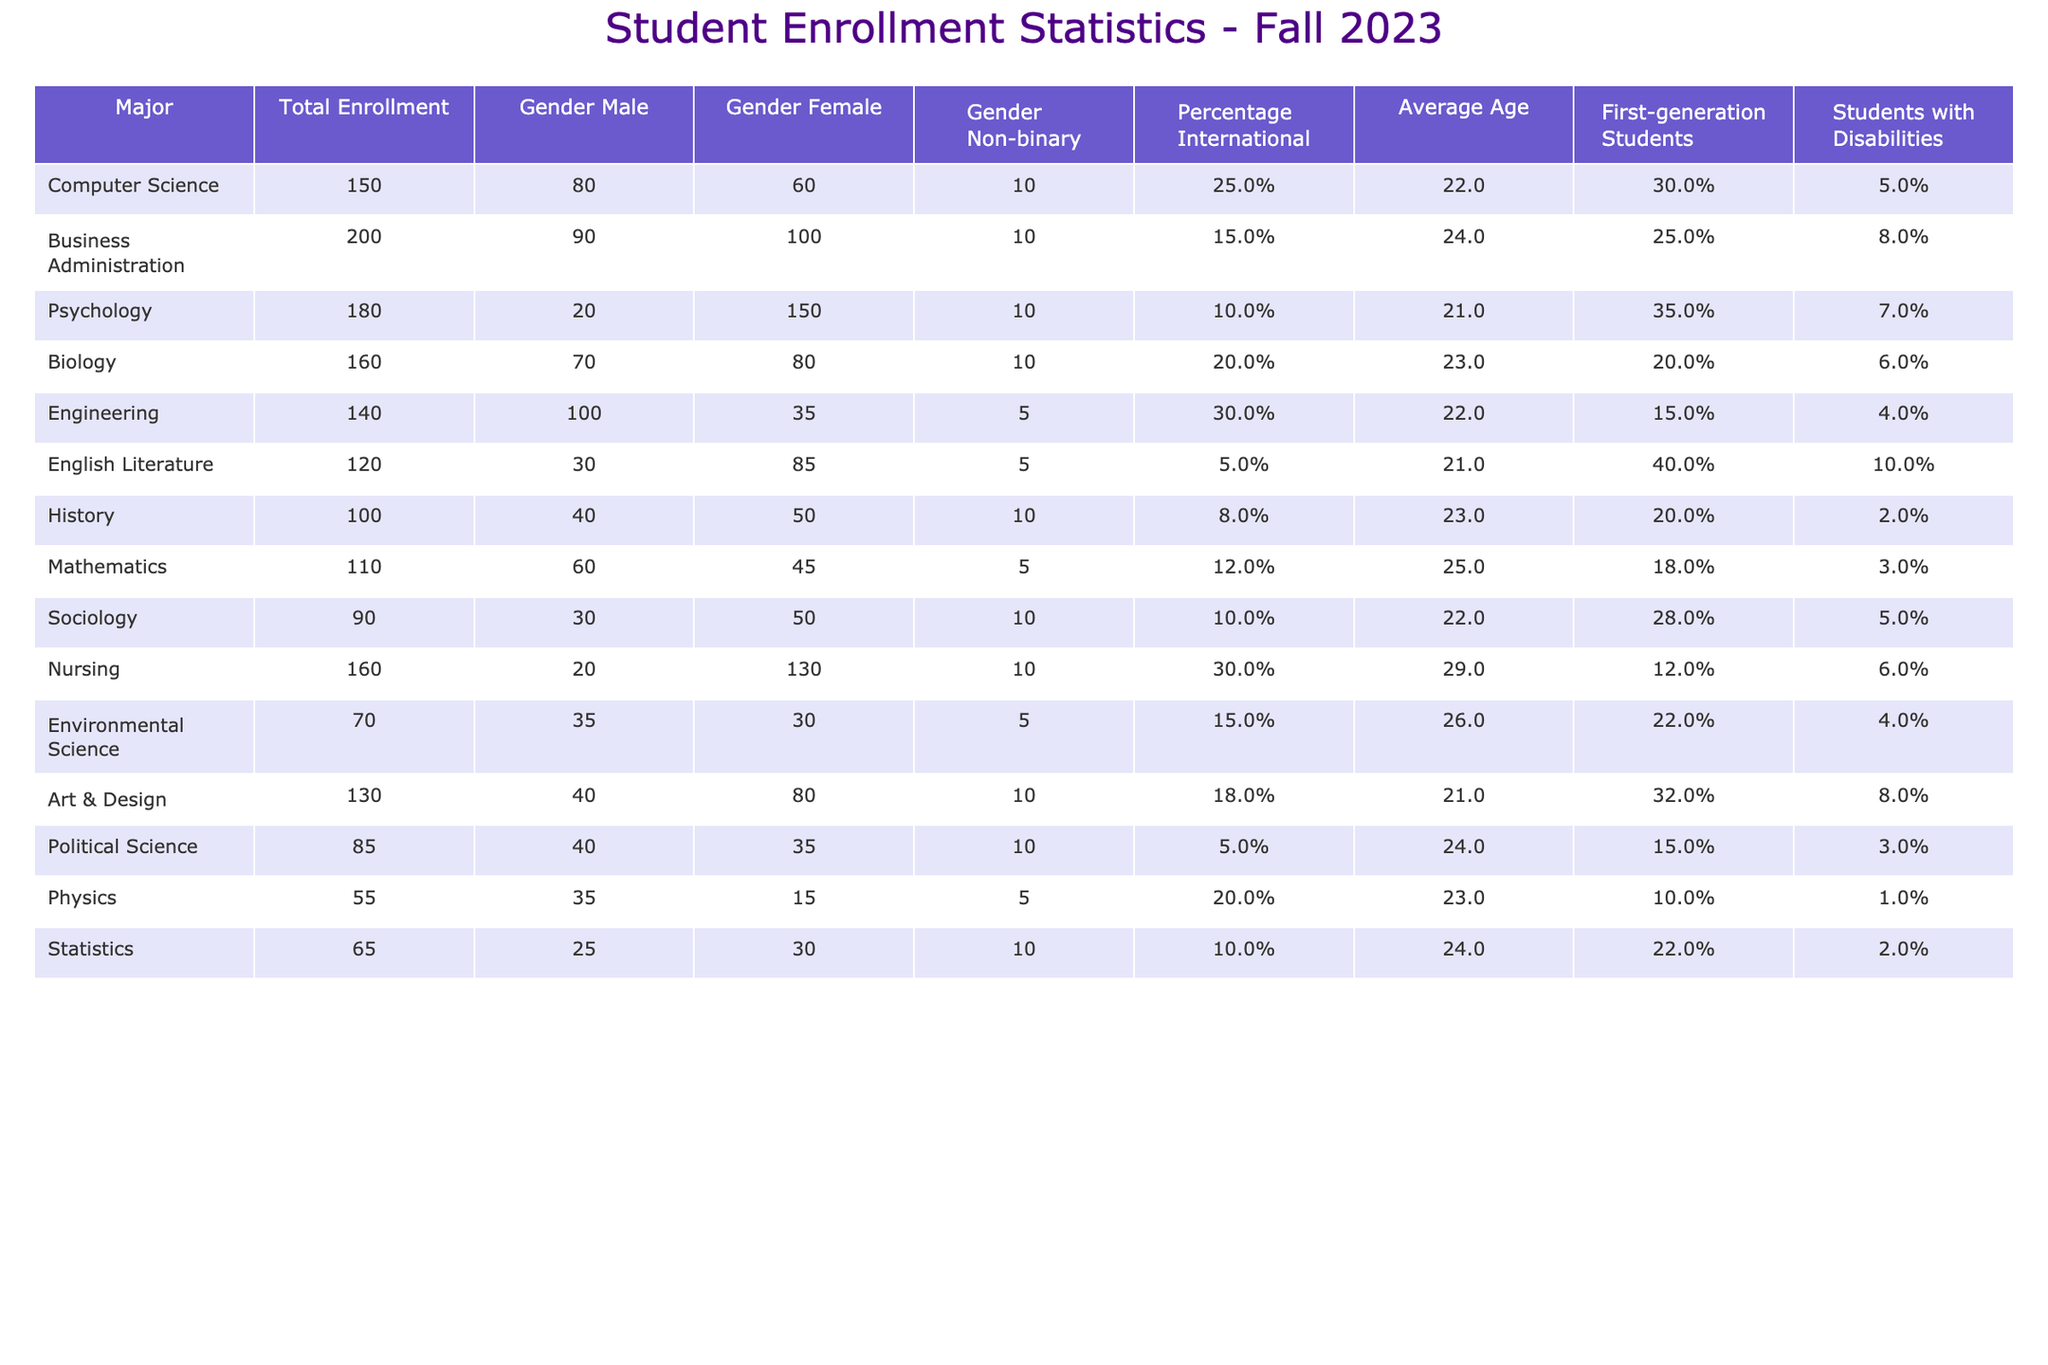What is the total enrollment for Computer Science? The table shows the "Total Enrollment" column for each major, where Computer Science has a recorded value of 150.
Answer: 150 How many female students are enrolled in Nursing? In the Nursing row under "Gender Female", the number of female students is 130.
Answer: 130 What is the average age of students in the Psychology major? The table lists the "Average Age" for the Psychology major as 21 years.
Answer: 21 Are there more male or female students in Business Administration? The numbers indicate that there are 90 male and 100 female students. Since 100 is greater than 90, there are more female students.
Answer: Yes Which major has the highest percentage of international students? Looking at the "Percentage International" column, Engineering has the highest percentage at 30%.
Answer: Engineering How many total students are enrolled in majors that have at least 150 students? The majors with an enrollment of at least 150 are Computer Science (150), Business Administration (200), and Nursing (160). Adding these together: 150 + 200 + 160 = 510.
Answer: 510 What is the difference in the total enrollment between Biology and Mathematics? Total Enrollment for Biology is 160 and for Mathematics is 110. The difference is calculated as 160 - 110 = 50.
Answer: 50 In which major are students with disabilities the most prevalent, based on percentage? The highest percentage of "Students with Disabilities" is in English Literature with 10%.
Answer: English Literature If a student is enrolled in Sociology, what is the average age of their peers in that major? Under Sociology, the "Average Age" listed is 22 years, which represents the average age of students in that major.
Answer: 22 How much more likely are first-generation students to be in Psychology compared to Nursing, in percentage terms? Psychology has 35% first-generation students and Nursing has 12%. The difference is 35% - 12% = 23%.
Answer: 23% 